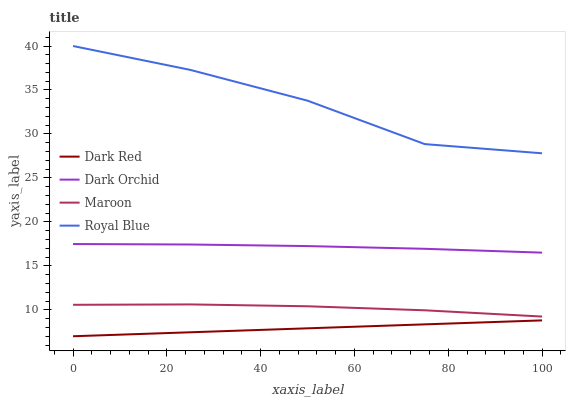Does Dark Red have the minimum area under the curve?
Answer yes or no. Yes. Does Royal Blue have the maximum area under the curve?
Answer yes or no. Yes. Does Maroon have the minimum area under the curve?
Answer yes or no. No. Does Maroon have the maximum area under the curve?
Answer yes or no. No. Is Dark Red the smoothest?
Answer yes or no. Yes. Is Royal Blue the roughest?
Answer yes or no. Yes. Is Maroon the smoothest?
Answer yes or no. No. Is Maroon the roughest?
Answer yes or no. No. Does Dark Red have the lowest value?
Answer yes or no. Yes. Does Maroon have the lowest value?
Answer yes or no. No. Does Royal Blue have the highest value?
Answer yes or no. Yes. Does Maroon have the highest value?
Answer yes or no. No. Is Dark Red less than Royal Blue?
Answer yes or no. Yes. Is Royal Blue greater than Dark Orchid?
Answer yes or no. Yes. Does Dark Red intersect Royal Blue?
Answer yes or no. No. 